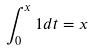Convert formula to latex. <formula><loc_0><loc_0><loc_500><loc_500>\int _ { 0 } ^ { x } 1 d t = x</formula> 